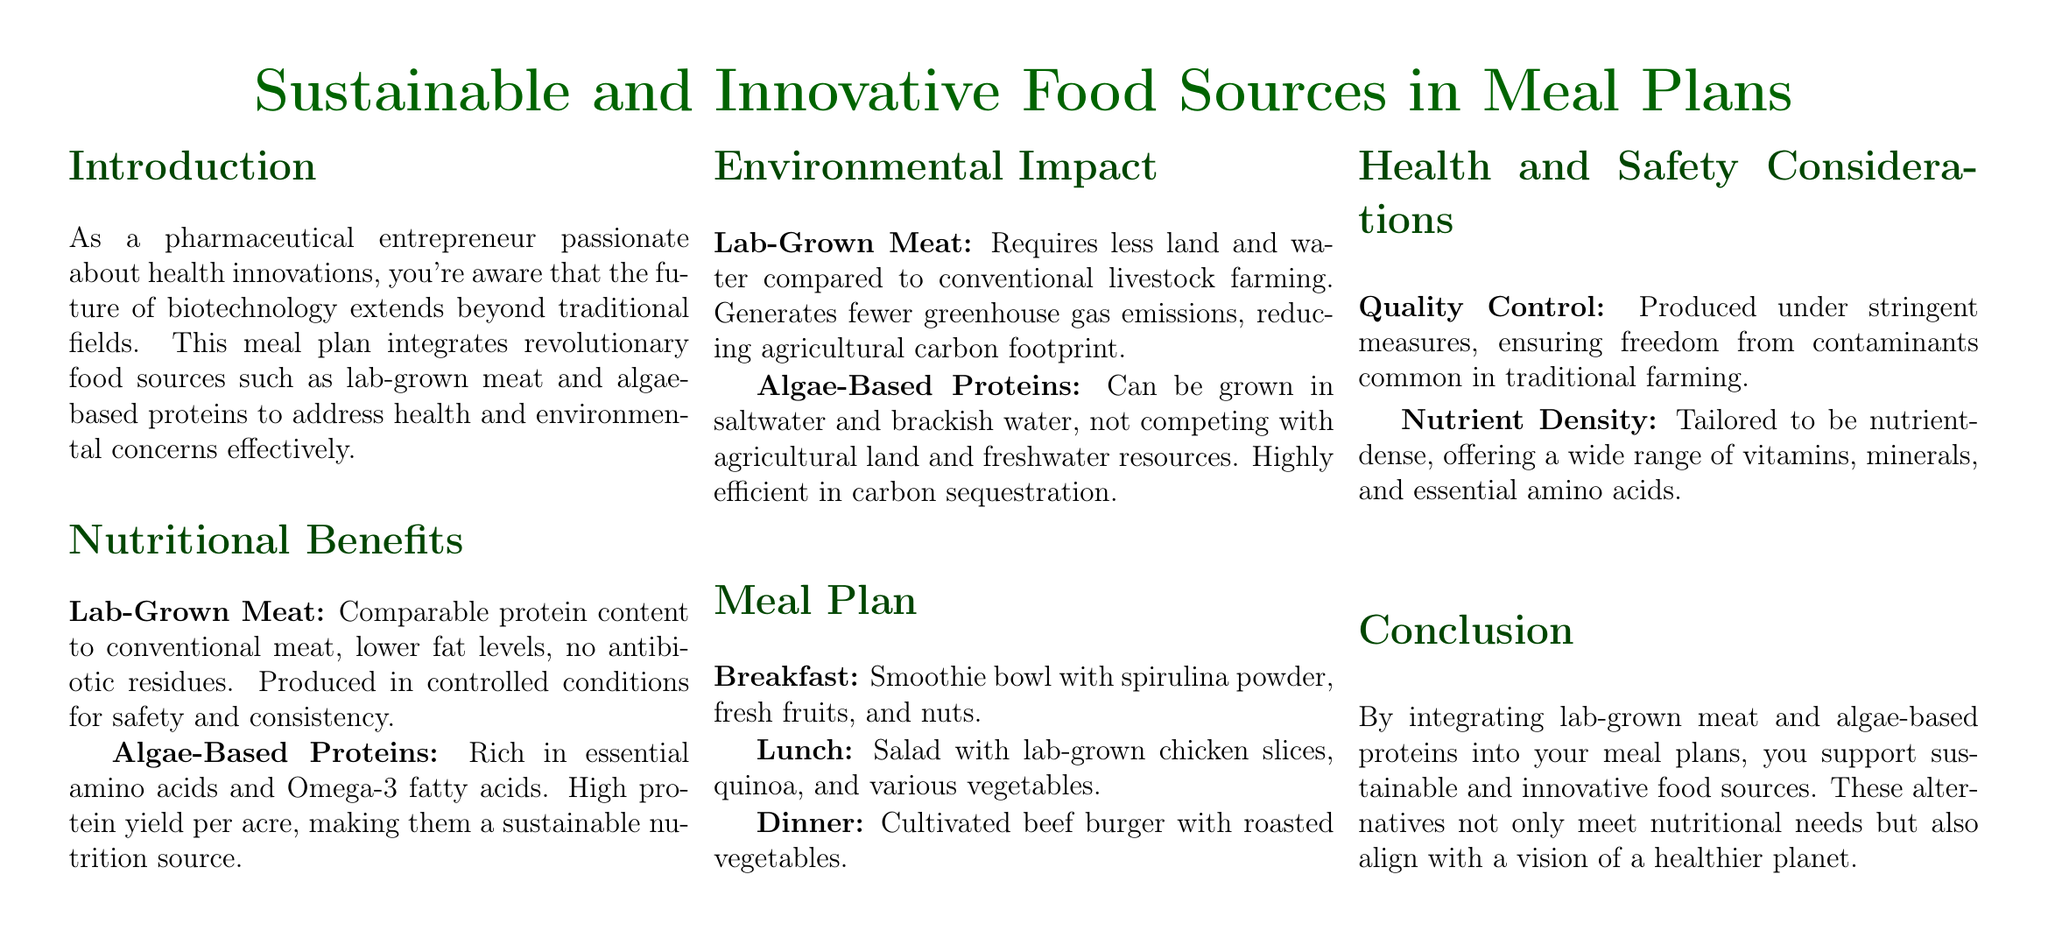What is the main focus of the meal plan? The meal plan focuses on integrating sustainable and innovative food sources, emphasizing health innovations.
Answer: Health innovations What proteins are highlighted in the meal plan? The meal plan emphasizes lab-grown meat and algae-based proteins as key nutritional sources.
Answer: Lab-grown meat and algae-based proteins What is included in the breakfast section? The breakfast section describes a smoothie bowl made with spirulina powder, fresh fruits, and nuts.
Answer: Smoothie bowl with spirulina powder How does lab-grown meat impact land use? The document states that lab-grown meat requires less land compared to conventional livestock farming.
Answer: Less land What health aspect is controlled in the production of lab-grown meat? The production of lab-grown meat is conducted under stringent quality control measures to ensure safety.
Answer: Quality control How is the protein yield of algae-based proteins characterized? The meal plan mentions that algae-based proteins have a high protein yield per acre, making them sustainable.
Answer: High protein yield What is the main environmental benefit of algae-based proteins? Algae-based proteins can grow in saltwater and brackish water, not competing with agricultural land.
Answer: Not competing with agricultural land What type of document is this meal plan categorized as? This document is categorized as a meal plan that integrates sustainable food sources.
Answer: Meal plan 